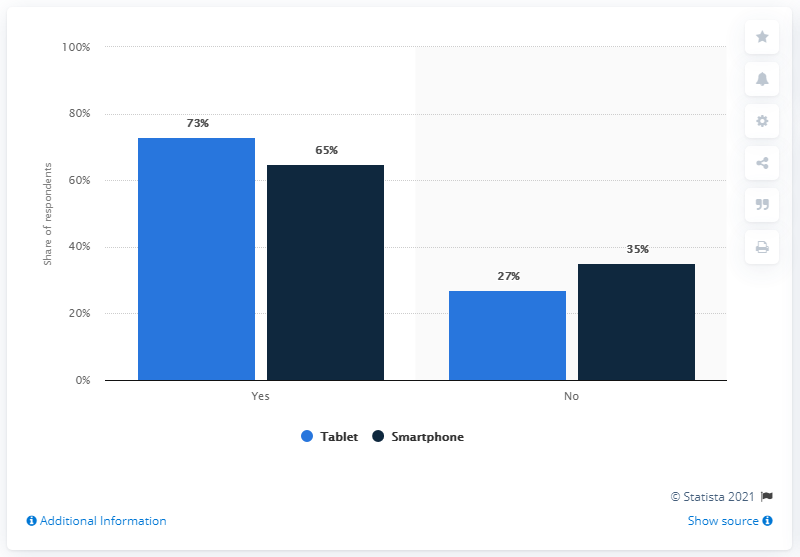Specify some key components in this picture. The ratio of navy blue bars for "Yes" and "No" is 1.857142857... According to a survey, 73% of parents have rules for their children when they use tablets. 